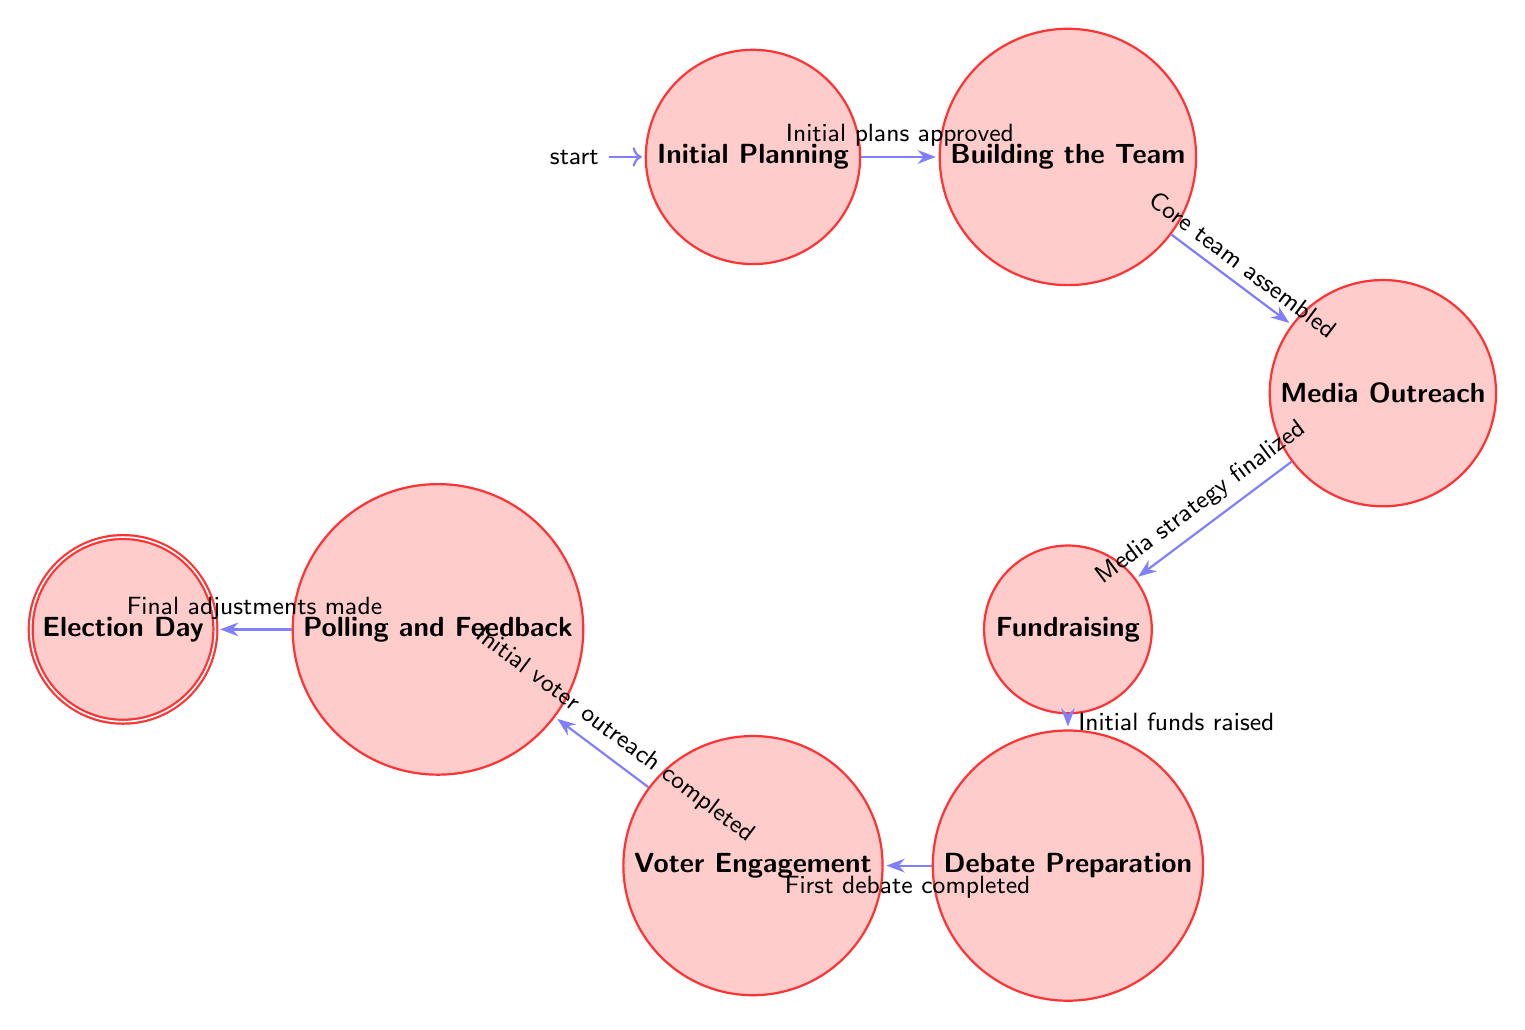What is the first node in the workflow? The first node in the workflow is "Initial Planning," which is labeled as the initial state in the diagram.
Answer: Initial Planning How many states are in the workflow? By counting the states listed in the diagram, we have a total of 8 states: Initial Planning, Building the Team, Media Outreach, Fundraising, Debate Preparation, Voter Engagement, Polling and Feedback, and Election Day.
Answer: 8 What action follows "Building the Team"? Following "Building the Team," the next action or state is "Media Outreach" as indicated by the transition from Building the Team to Media Outreach in the diagram.
Answer: Media Outreach What condition is required to move from "Fundraising" to "Debate Preparation"? To transition from "Fundraising" to "Debate Preparation," the condition required is "Initial funds raised." This condition indicates the fundraising stage must successfully complete before proceeding.
Answer: Initial funds raised Which state directly leads to "Election Day"? The state that directly leads to "Election Day" is "Polling and Feedback," as indicated by the arrow connecting Polling and Feedback to Election Day in the diagram.
Answer: Polling and Feedback What is the total number of transitions in the diagram? By counting the transitions indicated in the diagram, there are 7 transitions connecting the states.
Answer: 7 Which state has the action "Organize community town halls"? The action "Organize community town halls" is part of the state "Voter Engagement," as listed under the actions for that state in the diagram.
Answer: Voter Engagement What must be finalized before "Media Outreach" can begin? Before "Media Outreach" can begin, the condition "Media strategy finalized" must be met, as shown in the transition from Media Outreach to Fundraising.
Answer: Media strategy finalized 